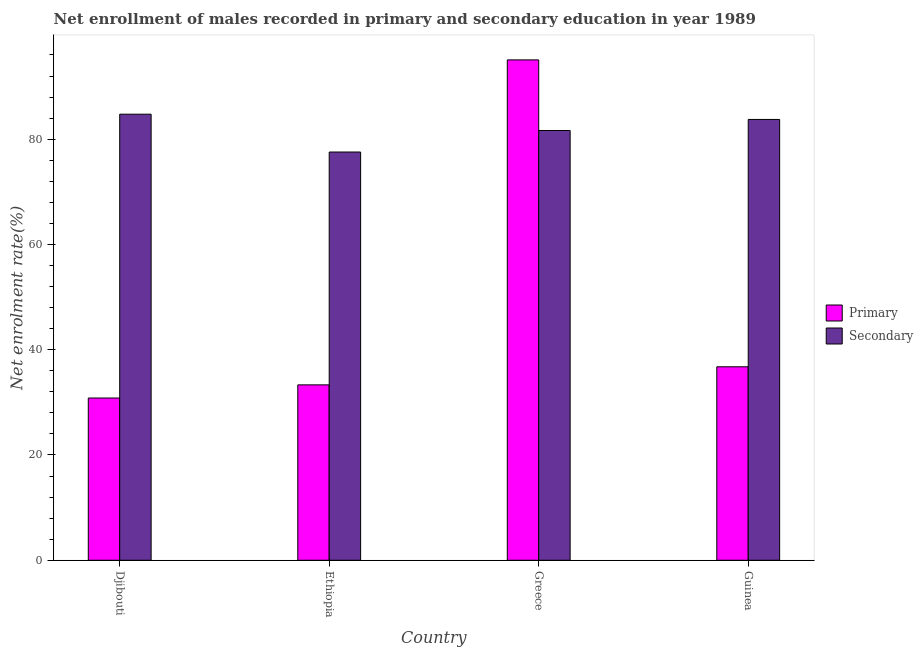Are the number of bars on each tick of the X-axis equal?
Give a very brief answer. Yes. How many bars are there on the 3rd tick from the left?
Your answer should be very brief. 2. What is the label of the 2nd group of bars from the left?
Offer a terse response. Ethiopia. What is the enrollment rate in primary education in Djibouti?
Give a very brief answer. 30.83. Across all countries, what is the maximum enrollment rate in secondary education?
Make the answer very short. 84.74. Across all countries, what is the minimum enrollment rate in secondary education?
Offer a terse response. 77.56. In which country was the enrollment rate in primary education minimum?
Offer a very short reply. Djibouti. What is the total enrollment rate in primary education in the graph?
Ensure brevity in your answer.  195.96. What is the difference between the enrollment rate in secondary education in Djibouti and that in Ethiopia?
Keep it short and to the point. 7.19. What is the difference between the enrollment rate in primary education in Djibouti and the enrollment rate in secondary education in Guinea?
Your answer should be compact. -52.92. What is the average enrollment rate in secondary education per country?
Provide a short and direct response. 81.92. What is the difference between the enrollment rate in secondary education and enrollment rate in primary education in Djibouti?
Provide a succinct answer. 53.92. What is the ratio of the enrollment rate in secondary education in Djibouti to that in Ethiopia?
Provide a succinct answer. 1.09. What is the difference between the highest and the second highest enrollment rate in secondary education?
Offer a very short reply. 1. What is the difference between the highest and the lowest enrollment rate in secondary education?
Offer a terse response. 7.19. In how many countries, is the enrollment rate in secondary education greater than the average enrollment rate in secondary education taken over all countries?
Keep it short and to the point. 2. What does the 1st bar from the left in Ethiopia represents?
Offer a very short reply. Primary. What does the 1st bar from the right in Guinea represents?
Your answer should be very brief. Secondary. How many bars are there?
Offer a very short reply. 8. Are all the bars in the graph horizontal?
Provide a short and direct response. No. What is the difference between two consecutive major ticks on the Y-axis?
Offer a terse response. 20. How are the legend labels stacked?
Offer a terse response. Vertical. What is the title of the graph?
Ensure brevity in your answer.  Net enrollment of males recorded in primary and secondary education in year 1989. What is the label or title of the Y-axis?
Your answer should be compact. Net enrolment rate(%). What is the Net enrolment rate(%) of Primary in Djibouti?
Provide a short and direct response. 30.83. What is the Net enrolment rate(%) of Secondary in Djibouti?
Your response must be concise. 84.74. What is the Net enrolment rate(%) of Primary in Ethiopia?
Keep it short and to the point. 33.32. What is the Net enrolment rate(%) in Secondary in Ethiopia?
Make the answer very short. 77.56. What is the Net enrolment rate(%) of Primary in Greece?
Give a very brief answer. 95.06. What is the Net enrolment rate(%) of Secondary in Greece?
Offer a terse response. 81.65. What is the Net enrolment rate(%) in Primary in Guinea?
Your answer should be compact. 36.76. What is the Net enrolment rate(%) of Secondary in Guinea?
Offer a very short reply. 83.75. Across all countries, what is the maximum Net enrolment rate(%) in Primary?
Your answer should be compact. 95.06. Across all countries, what is the maximum Net enrolment rate(%) in Secondary?
Your answer should be very brief. 84.74. Across all countries, what is the minimum Net enrolment rate(%) of Primary?
Provide a succinct answer. 30.83. Across all countries, what is the minimum Net enrolment rate(%) in Secondary?
Your answer should be compact. 77.56. What is the total Net enrolment rate(%) of Primary in the graph?
Give a very brief answer. 195.96. What is the total Net enrolment rate(%) of Secondary in the graph?
Your answer should be very brief. 327.7. What is the difference between the Net enrolment rate(%) in Primary in Djibouti and that in Ethiopia?
Keep it short and to the point. -2.5. What is the difference between the Net enrolment rate(%) of Secondary in Djibouti and that in Ethiopia?
Your answer should be compact. 7.19. What is the difference between the Net enrolment rate(%) in Primary in Djibouti and that in Greece?
Offer a very short reply. -64.24. What is the difference between the Net enrolment rate(%) of Secondary in Djibouti and that in Greece?
Provide a short and direct response. 3.1. What is the difference between the Net enrolment rate(%) of Primary in Djibouti and that in Guinea?
Your answer should be very brief. -5.93. What is the difference between the Net enrolment rate(%) in Primary in Ethiopia and that in Greece?
Keep it short and to the point. -61.74. What is the difference between the Net enrolment rate(%) of Secondary in Ethiopia and that in Greece?
Offer a terse response. -4.09. What is the difference between the Net enrolment rate(%) of Primary in Ethiopia and that in Guinea?
Provide a short and direct response. -3.44. What is the difference between the Net enrolment rate(%) of Secondary in Ethiopia and that in Guinea?
Your answer should be very brief. -6.19. What is the difference between the Net enrolment rate(%) of Primary in Greece and that in Guinea?
Give a very brief answer. 58.3. What is the difference between the Net enrolment rate(%) of Secondary in Greece and that in Guinea?
Your answer should be compact. -2.1. What is the difference between the Net enrolment rate(%) in Primary in Djibouti and the Net enrolment rate(%) in Secondary in Ethiopia?
Offer a terse response. -46.73. What is the difference between the Net enrolment rate(%) of Primary in Djibouti and the Net enrolment rate(%) of Secondary in Greece?
Offer a terse response. -50.82. What is the difference between the Net enrolment rate(%) in Primary in Djibouti and the Net enrolment rate(%) in Secondary in Guinea?
Offer a terse response. -52.92. What is the difference between the Net enrolment rate(%) in Primary in Ethiopia and the Net enrolment rate(%) in Secondary in Greece?
Give a very brief answer. -48.33. What is the difference between the Net enrolment rate(%) in Primary in Ethiopia and the Net enrolment rate(%) in Secondary in Guinea?
Give a very brief answer. -50.42. What is the difference between the Net enrolment rate(%) of Primary in Greece and the Net enrolment rate(%) of Secondary in Guinea?
Offer a terse response. 11.31. What is the average Net enrolment rate(%) in Primary per country?
Give a very brief answer. 48.99. What is the average Net enrolment rate(%) of Secondary per country?
Keep it short and to the point. 81.92. What is the difference between the Net enrolment rate(%) of Primary and Net enrolment rate(%) of Secondary in Djibouti?
Provide a short and direct response. -53.92. What is the difference between the Net enrolment rate(%) of Primary and Net enrolment rate(%) of Secondary in Ethiopia?
Give a very brief answer. -44.24. What is the difference between the Net enrolment rate(%) in Primary and Net enrolment rate(%) in Secondary in Greece?
Offer a terse response. 13.41. What is the difference between the Net enrolment rate(%) of Primary and Net enrolment rate(%) of Secondary in Guinea?
Your answer should be compact. -46.99. What is the ratio of the Net enrolment rate(%) of Primary in Djibouti to that in Ethiopia?
Keep it short and to the point. 0.93. What is the ratio of the Net enrolment rate(%) of Secondary in Djibouti to that in Ethiopia?
Provide a succinct answer. 1.09. What is the ratio of the Net enrolment rate(%) in Primary in Djibouti to that in Greece?
Ensure brevity in your answer.  0.32. What is the ratio of the Net enrolment rate(%) of Secondary in Djibouti to that in Greece?
Offer a terse response. 1.04. What is the ratio of the Net enrolment rate(%) of Primary in Djibouti to that in Guinea?
Keep it short and to the point. 0.84. What is the ratio of the Net enrolment rate(%) of Secondary in Djibouti to that in Guinea?
Your answer should be compact. 1.01. What is the ratio of the Net enrolment rate(%) in Primary in Ethiopia to that in Greece?
Provide a succinct answer. 0.35. What is the ratio of the Net enrolment rate(%) in Secondary in Ethiopia to that in Greece?
Your answer should be compact. 0.95. What is the ratio of the Net enrolment rate(%) in Primary in Ethiopia to that in Guinea?
Offer a terse response. 0.91. What is the ratio of the Net enrolment rate(%) in Secondary in Ethiopia to that in Guinea?
Provide a succinct answer. 0.93. What is the ratio of the Net enrolment rate(%) in Primary in Greece to that in Guinea?
Your answer should be very brief. 2.59. What is the ratio of the Net enrolment rate(%) of Secondary in Greece to that in Guinea?
Provide a succinct answer. 0.97. What is the difference between the highest and the second highest Net enrolment rate(%) in Primary?
Give a very brief answer. 58.3. What is the difference between the highest and the second highest Net enrolment rate(%) of Secondary?
Make the answer very short. 1. What is the difference between the highest and the lowest Net enrolment rate(%) in Primary?
Give a very brief answer. 64.24. What is the difference between the highest and the lowest Net enrolment rate(%) in Secondary?
Your answer should be very brief. 7.19. 